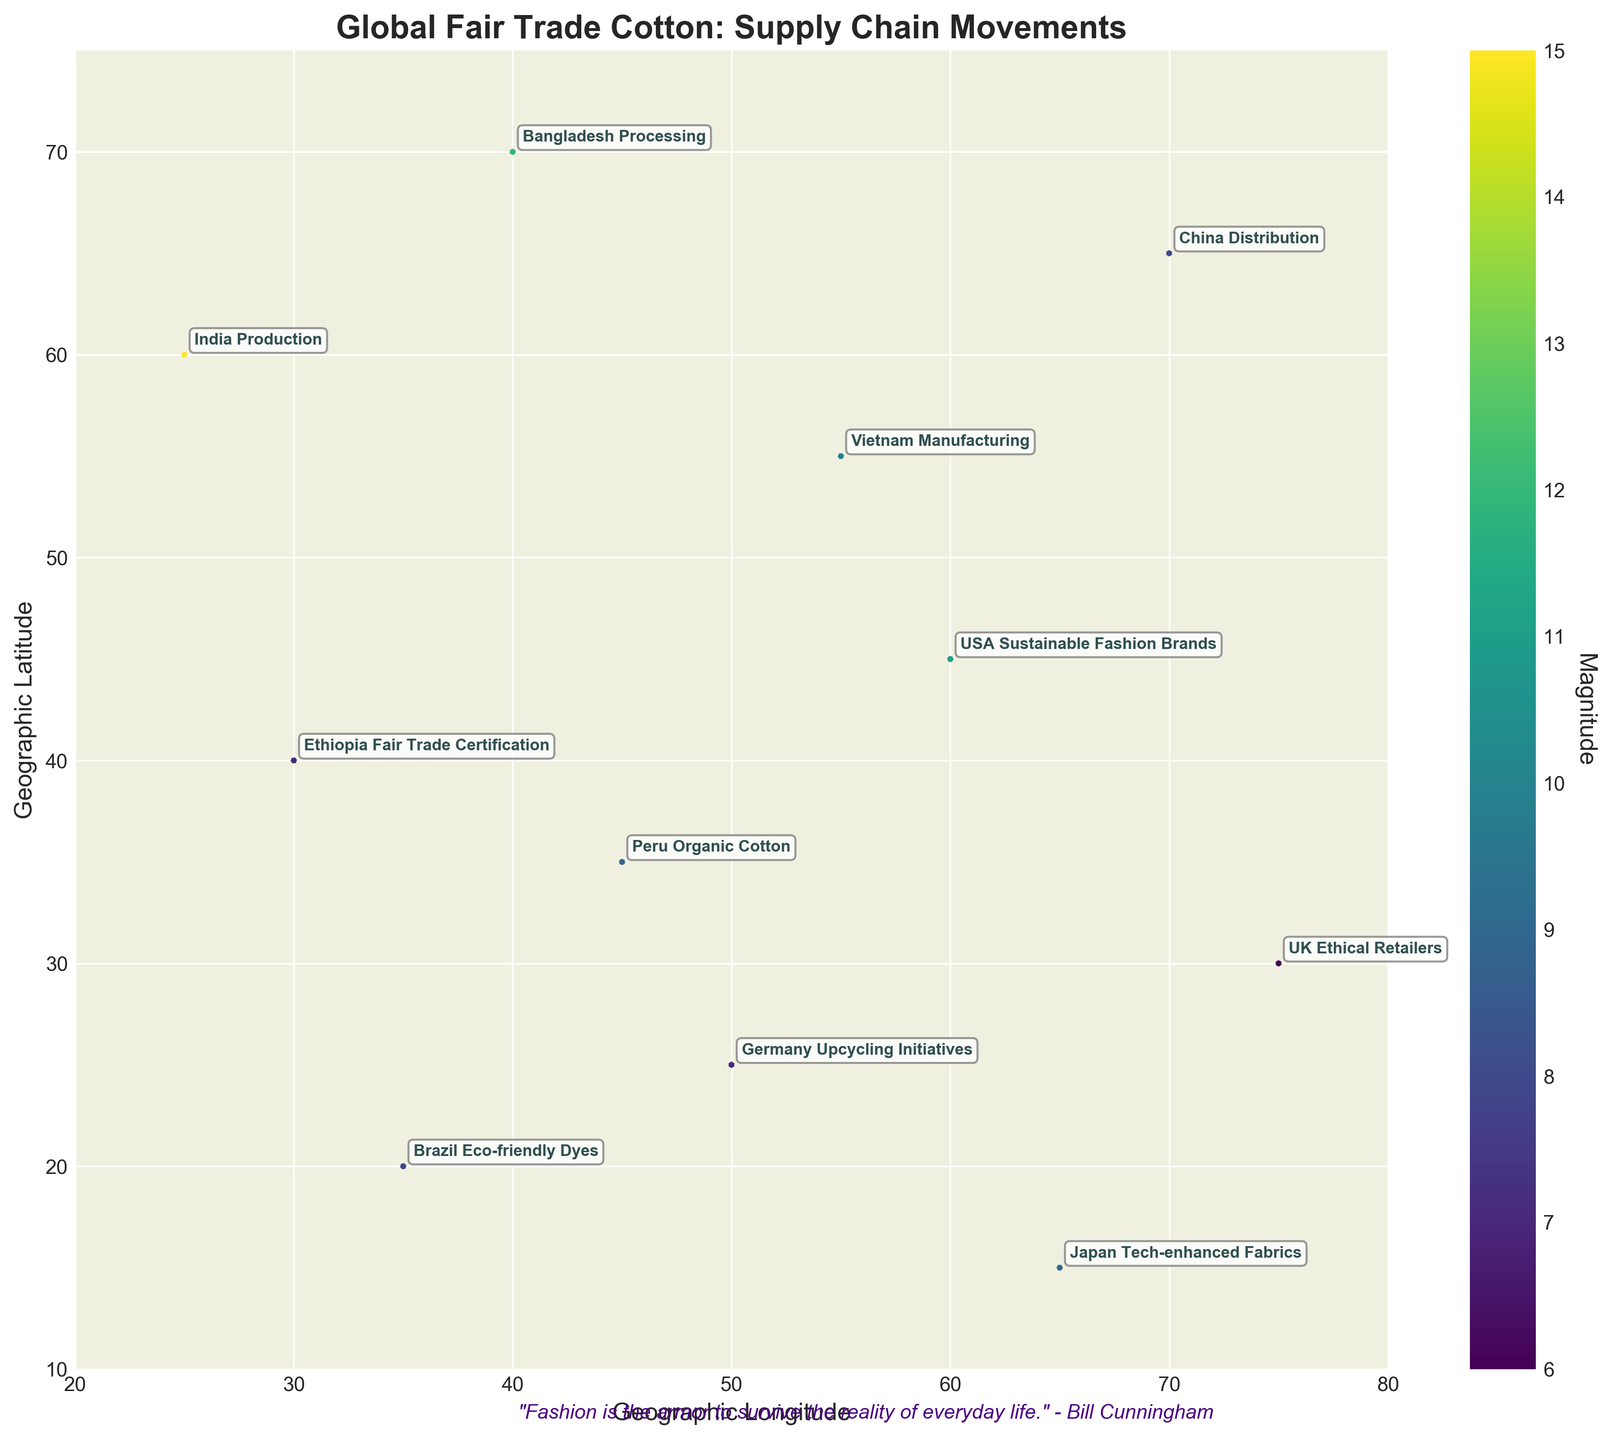What is the title of the figure? The title of the figure is typically displayed at the top and provides a brief description of the plot. In this figure, the title is displayed as “Global Fair Trade Cotton: Supply Chain Movements”.
Answer: Global Fair Trade Cotton: Supply Chain Movements Which region has the highest magnitude value in the plot? The highest magnitude value can be identified by looking at the color intensity from the color bar. In this figure, the region labeled "India Production" has the highest magnitude value of 15, indicated by the darker color.
Answer: India Production What is the range of values on the y-axis? The y-axis range is determined by the vertical extent from the minimum to the maximum value marked on the axis. In this figure, the range of values on the y-axis goes from 10 to 75.
Answer: 10 to 75 How many data points are depicted in the plot? Each arrow on the quiver plot represents a data point. By counting the number of arrows or labeled points in the figure, we find that there are 11 data points.
Answer: 11 What is the geographic location of the "USA Sustainable Fashion Brands"? The geographic location on the plot is determined by the coordinates (x, y). For "USA Sustainable Fashion Brands", its coordinates are (60, 45).
Answer: (60, 45) Which two regions indicate movement toward the North-West direction in the figure? To determine the direction, examine the arrows where the components point towards the top-left (North-West). In the figure, both "India Production" and "Germany Upcycling Initiatives" have arrows pointing in the North-West direction.
Answer: India Production and Germany Upcycling Initiatives What is the average magnitude of all data points in the plot? To find the average magnitude, sum all the magnitude values and then divide by the number of data points: (15 + 12 + 10 + 8 + 7 + 9 + 11 + 6 + 8 + 7 + 9) / 11. This totals to 102, giving an average magnitude of 102/11 = 9.27.
Answer: 9.27 Which direction does the "Japan Tech-enhanced Fabrics" movement indicate? The direction of movement is determined by the vector (u, v). For "Japan Tech-enhanced Fabrics", the vector is (3, -7), indicating a movement towards the South-East.
Answer: South-East How does the movement direction of "Bangladesh Processing" compare to "China Distribution"? "Bangladesh Processing" shows a vector (8, -6), indicating movement towards the South-West, while "China Distribution" has a vector (6, 4), indicating movement towards the North-East. The movements are in opposite diagonal directions.
Answer: Opposite diagonal directions 